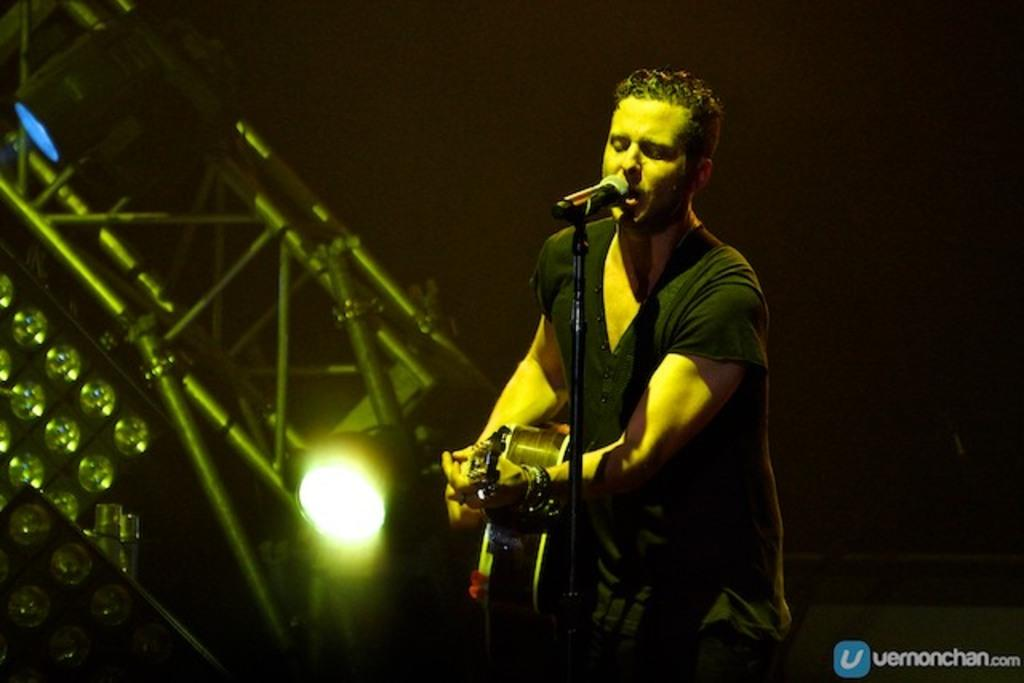What can be seen in the image that provides illumination? There are lights in the image. Who is present in the image? There is a man standing in the image. What is the man holding in the image? The man is holding a guitar. What is the man doing with the microphone in the image? The man is singing into a microphone. What type of jam is the man eating while playing the guitar in the image? There is no jam present in the image; the man is holding a guitar and singing into a microphone. How many ducks are visible in the image? There are no ducks present in the image. 